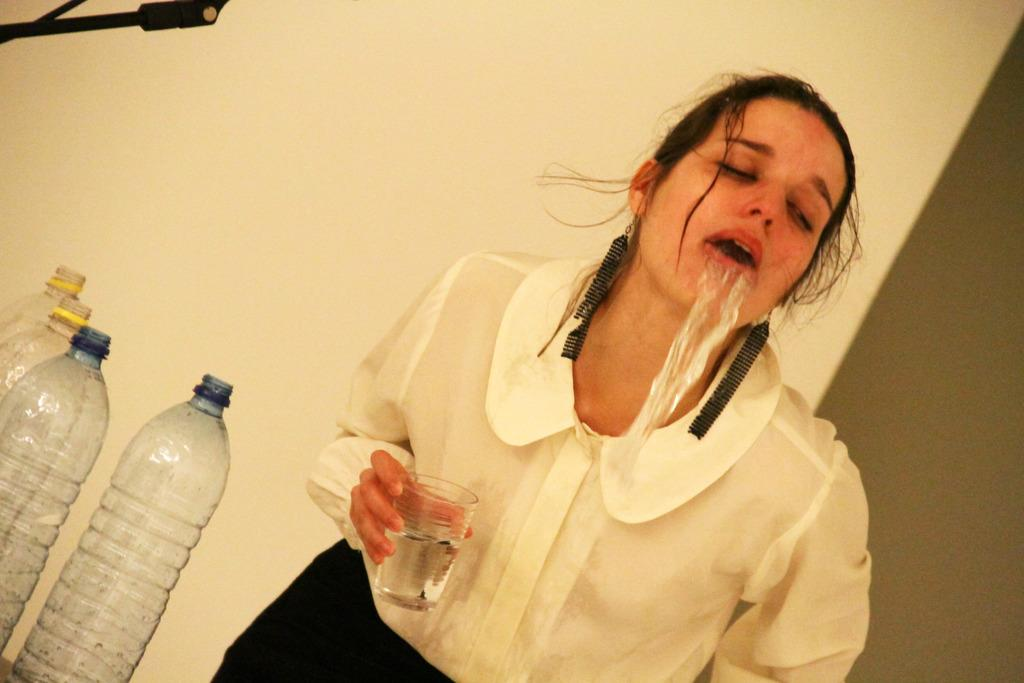What is the person in the image doing? The person is standing in the image and holding a glass. What is the person doing with the glass? The person is throwing up water from the glass. Are there any other objects visible in the image? Yes, there are bottles visible in the image. What is behind the person in the image? There is a wall behind the person. What does the thumb smell like in the image? There is no thumb present in the image, so it is not possible to determine what it might smell like. 